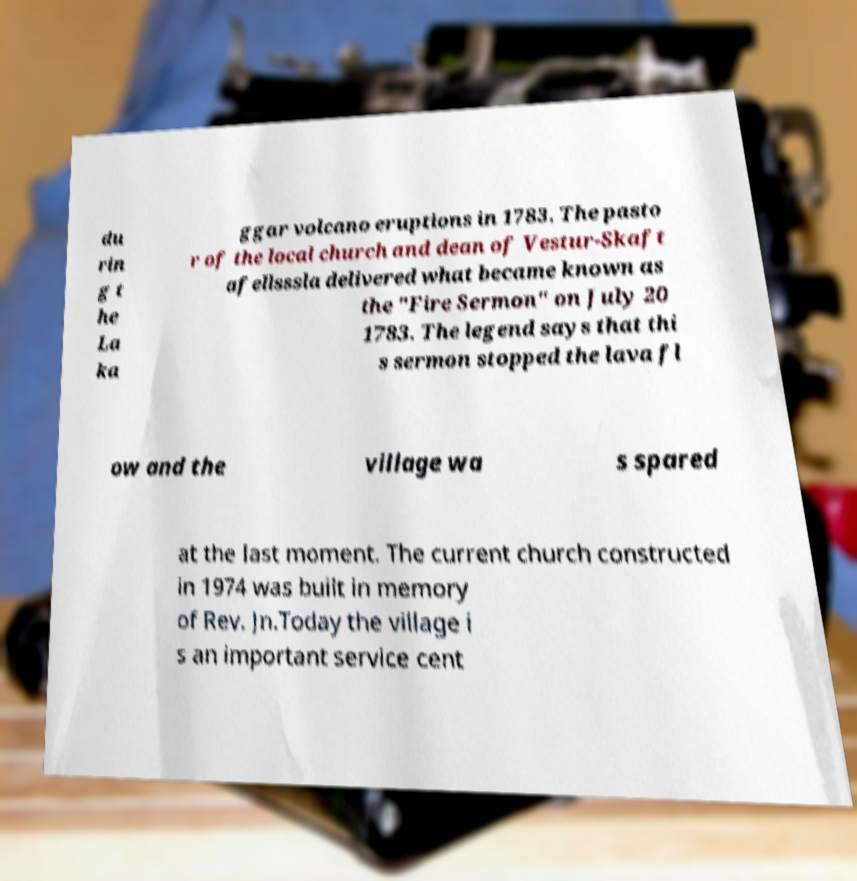Could you extract and type out the text from this image? du rin g t he La ka ggar volcano eruptions in 1783. The pasto r of the local church and dean of Vestur-Skaft afellsssla delivered what became known as the "Fire Sermon" on July 20 1783. The legend says that thi s sermon stopped the lava fl ow and the village wa s spared at the last moment. The current church constructed in 1974 was built in memory of Rev. Jn.Today the village i s an important service cent 